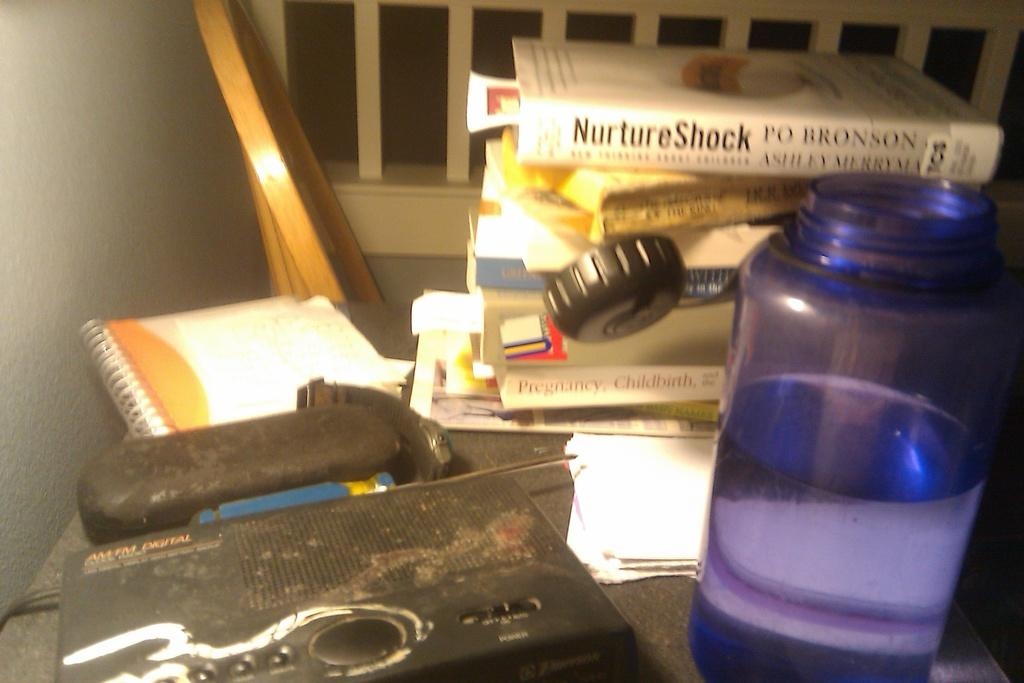<image>
Offer a succinct explanation of the picture presented. the word nurture is on the white book 